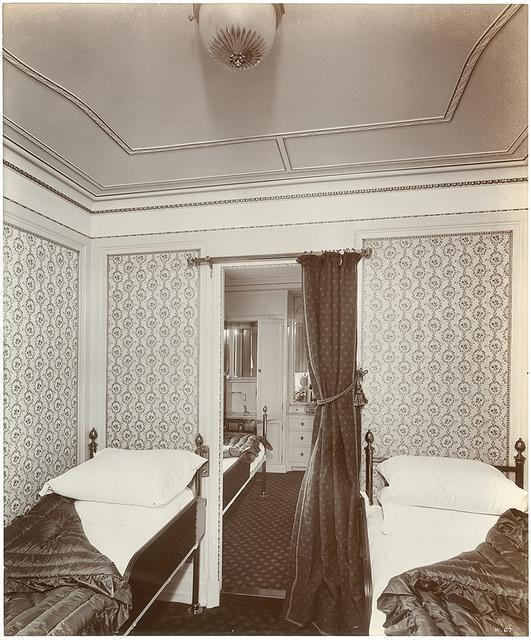How many beds can you see?
Give a very brief answer. 3. How many cars are to the left of the bus?
Give a very brief answer. 0. 